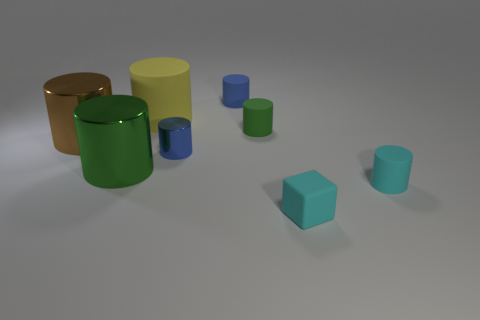Subtract all shiny cylinders. How many cylinders are left? 4 Add 1 green cylinders. How many objects exist? 9 Subtract all green spheres. How many blue cylinders are left? 2 Subtract all yellow cylinders. How many cylinders are left? 6 Subtract 1 cylinders. How many cylinders are left? 6 Subtract all cylinders. How many objects are left? 1 Subtract 0 purple cylinders. How many objects are left? 8 Subtract all gray blocks. Subtract all gray cylinders. How many blocks are left? 1 Subtract all green matte cylinders. Subtract all small blue matte cylinders. How many objects are left? 6 Add 7 green shiny objects. How many green shiny objects are left? 8 